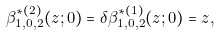<formula> <loc_0><loc_0><loc_500><loc_500>\beta ^ { \ast ( 2 ) } _ { 1 , 0 , 2 } ( z ; 0 ) = \delta \beta ^ { \ast ( 1 ) } _ { 1 , 0 , 2 } ( z ; 0 ) = z ,</formula> 